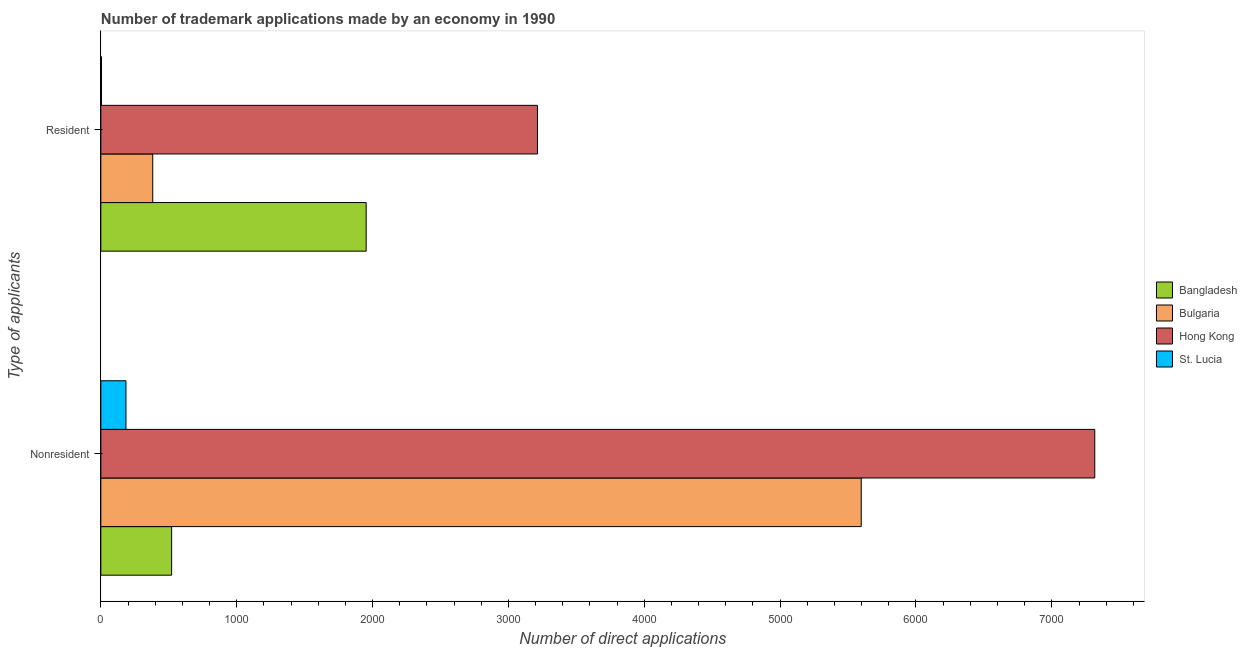How many bars are there on the 2nd tick from the top?
Offer a very short reply. 4. What is the label of the 2nd group of bars from the top?
Your answer should be compact. Nonresident. What is the number of trademark applications made by residents in Hong Kong?
Ensure brevity in your answer.  3214. Across all countries, what is the maximum number of trademark applications made by residents?
Keep it short and to the point. 3214. Across all countries, what is the minimum number of trademark applications made by non residents?
Offer a very short reply. 185. In which country was the number of trademark applications made by residents maximum?
Offer a terse response. Hong Kong. In which country was the number of trademark applications made by residents minimum?
Provide a short and direct response. St. Lucia. What is the total number of trademark applications made by non residents in the graph?
Your response must be concise. 1.36e+04. What is the difference between the number of trademark applications made by non residents in Bangladesh and that in St. Lucia?
Provide a succinct answer. 336. What is the difference between the number of trademark applications made by residents in Hong Kong and the number of trademark applications made by non residents in St. Lucia?
Your answer should be compact. 3029. What is the average number of trademark applications made by non residents per country?
Provide a short and direct response. 3404.75. What is the difference between the number of trademark applications made by residents and number of trademark applications made by non residents in Bulgaria?
Your answer should be compact. -5215. What is the ratio of the number of trademark applications made by residents in Bangladesh to that in Hong Kong?
Your response must be concise. 0.61. Is the number of trademark applications made by residents in Hong Kong less than that in Bulgaria?
Your answer should be compact. No. In how many countries, is the number of trademark applications made by residents greater than the average number of trademark applications made by residents taken over all countries?
Your answer should be very brief. 2. What does the 2nd bar from the top in Resident represents?
Give a very brief answer. Hong Kong. What does the 4th bar from the bottom in Resident represents?
Give a very brief answer. St. Lucia. Are all the bars in the graph horizontal?
Make the answer very short. Yes. What is the difference between two consecutive major ticks on the X-axis?
Offer a very short reply. 1000. Are the values on the major ticks of X-axis written in scientific E-notation?
Offer a very short reply. No. Does the graph contain grids?
Provide a short and direct response. No. Where does the legend appear in the graph?
Your response must be concise. Center right. How many legend labels are there?
Offer a terse response. 4. What is the title of the graph?
Your answer should be very brief. Number of trademark applications made by an economy in 1990. Does "Iran" appear as one of the legend labels in the graph?
Give a very brief answer. No. What is the label or title of the X-axis?
Offer a very short reply. Number of direct applications. What is the label or title of the Y-axis?
Your answer should be compact. Type of applicants. What is the Number of direct applications of Bangladesh in Nonresident?
Offer a terse response. 521. What is the Number of direct applications in Bulgaria in Nonresident?
Make the answer very short. 5597. What is the Number of direct applications of Hong Kong in Nonresident?
Offer a terse response. 7316. What is the Number of direct applications of St. Lucia in Nonresident?
Provide a succinct answer. 185. What is the Number of direct applications in Bangladesh in Resident?
Give a very brief answer. 1953. What is the Number of direct applications in Bulgaria in Resident?
Offer a very short reply. 382. What is the Number of direct applications of Hong Kong in Resident?
Offer a terse response. 3214. Across all Type of applicants, what is the maximum Number of direct applications in Bangladesh?
Your response must be concise. 1953. Across all Type of applicants, what is the maximum Number of direct applications in Bulgaria?
Your answer should be very brief. 5597. Across all Type of applicants, what is the maximum Number of direct applications in Hong Kong?
Ensure brevity in your answer.  7316. Across all Type of applicants, what is the maximum Number of direct applications of St. Lucia?
Make the answer very short. 185. Across all Type of applicants, what is the minimum Number of direct applications of Bangladesh?
Offer a very short reply. 521. Across all Type of applicants, what is the minimum Number of direct applications in Bulgaria?
Your answer should be compact. 382. Across all Type of applicants, what is the minimum Number of direct applications in Hong Kong?
Keep it short and to the point. 3214. What is the total Number of direct applications of Bangladesh in the graph?
Offer a very short reply. 2474. What is the total Number of direct applications in Bulgaria in the graph?
Offer a terse response. 5979. What is the total Number of direct applications of Hong Kong in the graph?
Offer a very short reply. 1.05e+04. What is the total Number of direct applications of St. Lucia in the graph?
Offer a very short reply. 190. What is the difference between the Number of direct applications in Bangladesh in Nonresident and that in Resident?
Your answer should be very brief. -1432. What is the difference between the Number of direct applications of Bulgaria in Nonresident and that in Resident?
Give a very brief answer. 5215. What is the difference between the Number of direct applications of Hong Kong in Nonresident and that in Resident?
Your answer should be very brief. 4102. What is the difference between the Number of direct applications in St. Lucia in Nonresident and that in Resident?
Offer a terse response. 180. What is the difference between the Number of direct applications in Bangladesh in Nonresident and the Number of direct applications in Bulgaria in Resident?
Keep it short and to the point. 139. What is the difference between the Number of direct applications of Bangladesh in Nonresident and the Number of direct applications of Hong Kong in Resident?
Offer a very short reply. -2693. What is the difference between the Number of direct applications of Bangladesh in Nonresident and the Number of direct applications of St. Lucia in Resident?
Keep it short and to the point. 516. What is the difference between the Number of direct applications in Bulgaria in Nonresident and the Number of direct applications in Hong Kong in Resident?
Offer a very short reply. 2383. What is the difference between the Number of direct applications in Bulgaria in Nonresident and the Number of direct applications in St. Lucia in Resident?
Provide a short and direct response. 5592. What is the difference between the Number of direct applications of Hong Kong in Nonresident and the Number of direct applications of St. Lucia in Resident?
Offer a terse response. 7311. What is the average Number of direct applications in Bangladesh per Type of applicants?
Your answer should be very brief. 1237. What is the average Number of direct applications of Bulgaria per Type of applicants?
Your response must be concise. 2989.5. What is the average Number of direct applications of Hong Kong per Type of applicants?
Ensure brevity in your answer.  5265. What is the average Number of direct applications of St. Lucia per Type of applicants?
Your answer should be very brief. 95. What is the difference between the Number of direct applications in Bangladesh and Number of direct applications in Bulgaria in Nonresident?
Your answer should be compact. -5076. What is the difference between the Number of direct applications in Bangladesh and Number of direct applications in Hong Kong in Nonresident?
Provide a succinct answer. -6795. What is the difference between the Number of direct applications of Bangladesh and Number of direct applications of St. Lucia in Nonresident?
Provide a succinct answer. 336. What is the difference between the Number of direct applications in Bulgaria and Number of direct applications in Hong Kong in Nonresident?
Keep it short and to the point. -1719. What is the difference between the Number of direct applications in Bulgaria and Number of direct applications in St. Lucia in Nonresident?
Give a very brief answer. 5412. What is the difference between the Number of direct applications in Hong Kong and Number of direct applications in St. Lucia in Nonresident?
Your answer should be very brief. 7131. What is the difference between the Number of direct applications in Bangladesh and Number of direct applications in Bulgaria in Resident?
Offer a terse response. 1571. What is the difference between the Number of direct applications of Bangladesh and Number of direct applications of Hong Kong in Resident?
Your answer should be very brief. -1261. What is the difference between the Number of direct applications of Bangladesh and Number of direct applications of St. Lucia in Resident?
Your answer should be compact. 1948. What is the difference between the Number of direct applications in Bulgaria and Number of direct applications in Hong Kong in Resident?
Offer a very short reply. -2832. What is the difference between the Number of direct applications of Bulgaria and Number of direct applications of St. Lucia in Resident?
Your answer should be compact. 377. What is the difference between the Number of direct applications in Hong Kong and Number of direct applications in St. Lucia in Resident?
Your answer should be very brief. 3209. What is the ratio of the Number of direct applications in Bangladesh in Nonresident to that in Resident?
Ensure brevity in your answer.  0.27. What is the ratio of the Number of direct applications of Bulgaria in Nonresident to that in Resident?
Keep it short and to the point. 14.65. What is the ratio of the Number of direct applications in Hong Kong in Nonresident to that in Resident?
Provide a succinct answer. 2.28. What is the difference between the highest and the second highest Number of direct applications of Bangladesh?
Your answer should be very brief. 1432. What is the difference between the highest and the second highest Number of direct applications in Bulgaria?
Provide a succinct answer. 5215. What is the difference between the highest and the second highest Number of direct applications in Hong Kong?
Ensure brevity in your answer.  4102. What is the difference between the highest and the second highest Number of direct applications in St. Lucia?
Give a very brief answer. 180. What is the difference between the highest and the lowest Number of direct applications in Bangladesh?
Your answer should be compact. 1432. What is the difference between the highest and the lowest Number of direct applications of Bulgaria?
Make the answer very short. 5215. What is the difference between the highest and the lowest Number of direct applications of Hong Kong?
Your answer should be compact. 4102. What is the difference between the highest and the lowest Number of direct applications in St. Lucia?
Your response must be concise. 180. 